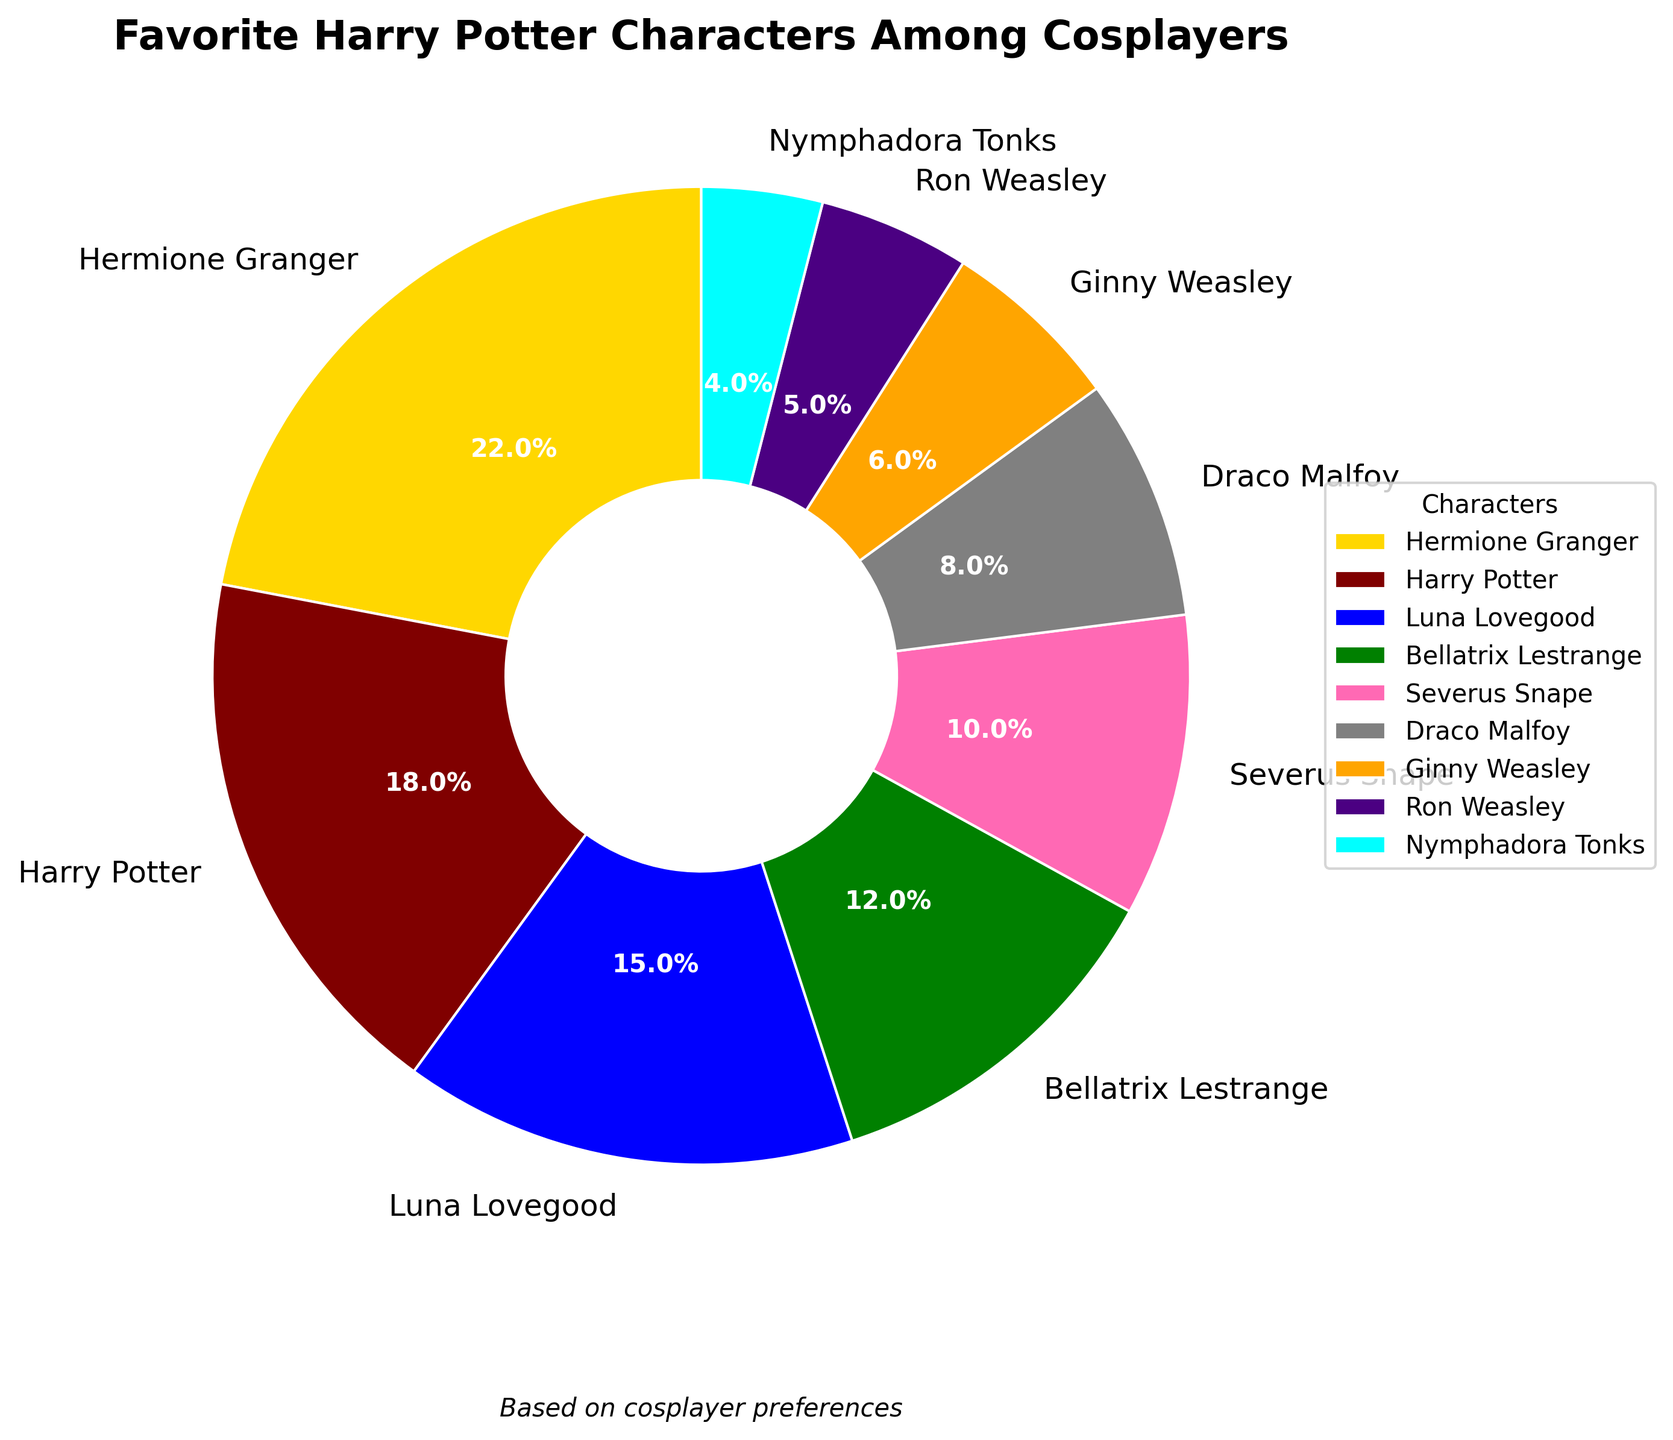Which character is the most favorite among cosplayers? The character with the highest percentage in the pie chart is the most favorite. Hermione Granger leads with 22%.
Answer: Hermione Granger Which character is the least favorite among cosplayers? The character with the lowest percentage in the pie chart is the least favorite. Nymphadora Tonks has the smallest share with 4%.
Answer: Nymphadora Tonks How much more do cosplayers favor Hermione Granger over Draco Malfoy? To find out, subtract Draco Malfoy's percentage (8%) from Hermione Granger's percentage (22%). The difference is 22% - 8% = 14%.
Answer: 14% Which character is favored nearly twice as much as Ginny Weasley? Luna Lovegood is favored at 15%, which is close to twice Ginny Weasley's 6% (2 * 6% = 12%, close to 15%).
Answer: Luna Lovegood Combine the percentages of Harry Potter and Severus Snape. How do they compare to Hermione Granger's percentage? Sum of Harry Potter's and Severus Snape's percentages is 18% + 10% = 28%. Hermione Granger's percentage is 22%. 28% - 22% = 6% more than Hermione Granger.
Answer: 6% more Which character is represented by the pink-colored wedge? The pie chart tends to use distinct colors, and Bellatrix Lestrange is most likely represented by the pink-colored wedge (assuming standard plot colors).
Answer: Bellatrix Lestrange What is the total percentage of cosplayers favoring Gryffindor characters (Harry, Hermione, Ron, Ginny)? Add the percentages of Gryffindor characters: Hermione (22%), Harry (18%), Ron (5%), Ginny (6%). The total is 22% + 18% + 5% + 6% = 51%.
Answer: 51% How does the preference for Bellatrix Lestrange compare to that for Luna Lovegood? Bellatrix Lestrange is favored by 12% of cosplayers, whereas Luna Lovegood is favored by 15%. 15% - 12% = 3% more favor Luna.
Answer: 3% more Is any character's percentage exactly half of another's? Check if any percentage is half of another: Draco Malfoy (8%) is exactly half of Hermione Granger (16%), but 6% is not exactly half of 12%, etc. No exact half found.
Answer: No 